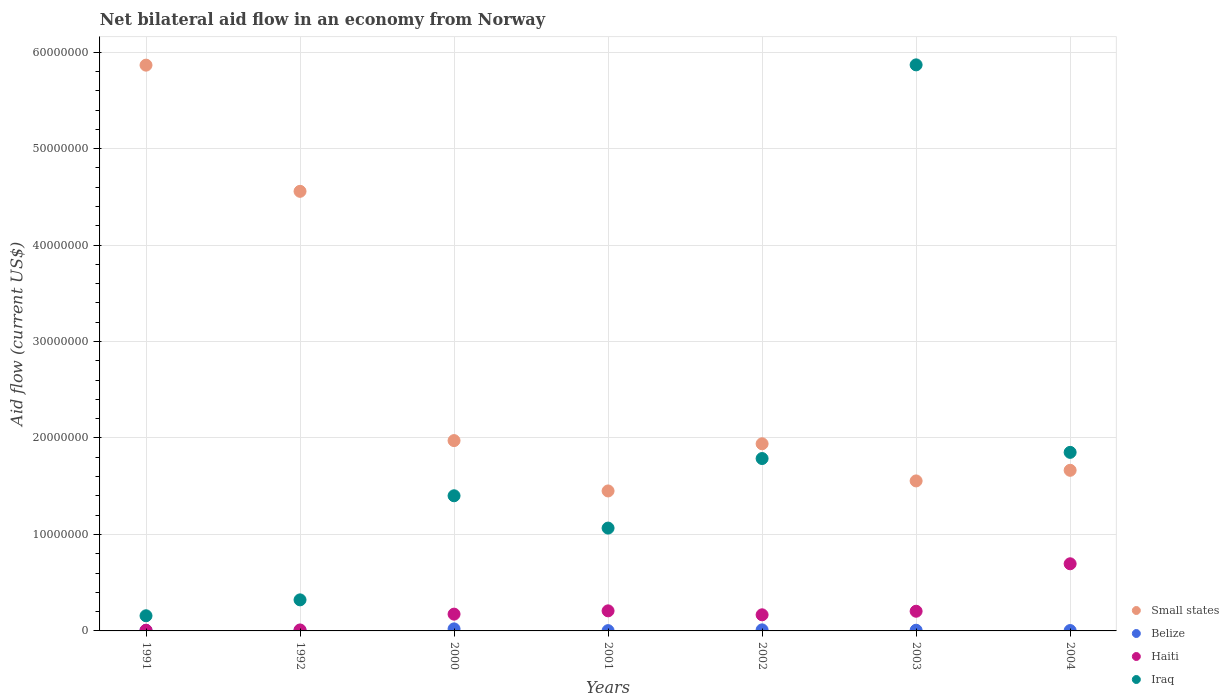Is the number of dotlines equal to the number of legend labels?
Provide a succinct answer. Yes. What is the net bilateral aid flow in Small states in 2000?
Give a very brief answer. 1.97e+07. Across all years, what is the maximum net bilateral aid flow in Iraq?
Make the answer very short. 5.87e+07. In which year was the net bilateral aid flow in Small states maximum?
Offer a terse response. 1991. What is the total net bilateral aid flow in Iraq in the graph?
Your answer should be compact. 1.25e+08. What is the difference between the net bilateral aid flow in Iraq in 1992 and that in 2003?
Keep it short and to the point. -5.55e+07. What is the difference between the net bilateral aid flow in Small states in 1991 and the net bilateral aid flow in Belize in 2002?
Provide a succinct answer. 5.85e+07. What is the average net bilateral aid flow in Small states per year?
Your answer should be compact. 2.72e+07. In the year 1992, what is the difference between the net bilateral aid flow in Iraq and net bilateral aid flow in Small states?
Ensure brevity in your answer.  -4.24e+07. In how many years, is the net bilateral aid flow in Haiti greater than 50000000 US$?
Give a very brief answer. 0. What is the ratio of the net bilateral aid flow in Iraq in 1991 to that in 2003?
Give a very brief answer. 0.03. Is the difference between the net bilateral aid flow in Iraq in 2000 and 2003 greater than the difference between the net bilateral aid flow in Small states in 2000 and 2003?
Offer a very short reply. No. What is the difference between the highest and the second highest net bilateral aid flow in Haiti?
Give a very brief answer. 4.88e+06. In how many years, is the net bilateral aid flow in Small states greater than the average net bilateral aid flow in Small states taken over all years?
Offer a very short reply. 2. Is it the case that in every year, the sum of the net bilateral aid flow in Iraq and net bilateral aid flow in Small states  is greater than the net bilateral aid flow in Belize?
Provide a short and direct response. Yes. Is the net bilateral aid flow in Haiti strictly less than the net bilateral aid flow in Small states over the years?
Provide a succinct answer. Yes. How many years are there in the graph?
Provide a short and direct response. 7. Does the graph contain any zero values?
Give a very brief answer. No. Does the graph contain grids?
Offer a very short reply. Yes. Where does the legend appear in the graph?
Give a very brief answer. Bottom right. How are the legend labels stacked?
Provide a succinct answer. Vertical. What is the title of the graph?
Provide a succinct answer. Net bilateral aid flow in an economy from Norway. What is the label or title of the X-axis?
Offer a very short reply. Years. What is the label or title of the Y-axis?
Ensure brevity in your answer.  Aid flow (current US$). What is the Aid flow (current US$) of Small states in 1991?
Keep it short and to the point. 5.86e+07. What is the Aid flow (current US$) in Belize in 1991?
Keep it short and to the point. 6.00e+04. What is the Aid flow (current US$) in Haiti in 1991?
Keep it short and to the point. 7.00e+04. What is the Aid flow (current US$) in Iraq in 1991?
Give a very brief answer. 1.57e+06. What is the Aid flow (current US$) of Small states in 1992?
Make the answer very short. 4.56e+07. What is the Aid flow (current US$) in Belize in 1992?
Your answer should be very brief. 6.00e+04. What is the Aid flow (current US$) of Haiti in 1992?
Offer a terse response. 1.00e+05. What is the Aid flow (current US$) of Iraq in 1992?
Offer a terse response. 3.22e+06. What is the Aid flow (current US$) in Small states in 2000?
Your answer should be very brief. 1.97e+07. What is the Aid flow (current US$) of Belize in 2000?
Ensure brevity in your answer.  2.10e+05. What is the Aid flow (current US$) in Haiti in 2000?
Your answer should be very brief. 1.74e+06. What is the Aid flow (current US$) in Iraq in 2000?
Your answer should be very brief. 1.40e+07. What is the Aid flow (current US$) in Small states in 2001?
Your answer should be compact. 1.45e+07. What is the Aid flow (current US$) of Haiti in 2001?
Your response must be concise. 2.08e+06. What is the Aid flow (current US$) of Iraq in 2001?
Ensure brevity in your answer.  1.07e+07. What is the Aid flow (current US$) of Small states in 2002?
Provide a succinct answer. 1.94e+07. What is the Aid flow (current US$) of Haiti in 2002?
Your answer should be very brief. 1.67e+06. What is the Aid flow (current US$) in Iraq in 2002?
Your response must be concise. 1.79e+07. What is the Aid flow (current US$) in Small states in 2003?
Your response must be concise. 1.56e+07. What is the Aid flow (current US$) of Belize in 2003?
Offer a terse response. 7.00e+04. What is the Aid flow (current US$) in Haiti in 2003?
Your response must be concise. 2.04e+06. What is the Aid flow (current US$) of Iraq in 2003?
Make the answer very short. 5.87e+07. What is the Aid flow (current US$) of Small states in 2004?
Provide a short and direct response. 1.66e+07. What is the Aid flow (current US$) in Belize in 2004?
Keep it short and to the point. 4.00e+04. What is the Aid flow (current US$) of Haiti in 2004?
Your answer should be very brief. 6.96e+06. What is the Aid flow (current US$) in Iraq in 2004?
Keep it short and to the point. 1.85e+07. Across all years, what is the maximum Aid flow (current US$) of Small states?
Provide a short and direct response. 5.86e+07. Across all years, what is the maximum Aid flow (current US$) in Haiti?
Your response must be concise. 6.96e+06. Across all years, what is the maximum Aid flow (current US$) of Iraq?
Provide a succinct answer. 5.87e+07. Across all years, what is the minimum Aid flow (current US$) of Small states?
Make the answer very short. 1.45e+07. Across all years, what is the minimum Aid flow (current US$) in Haiti?
Your response must be concise. 7.00e+04. Across all years, what is the minimum Aid flow (current US$) in Iraq?
Give a very brief answer. 1.57e+06. What is the total Aid flow (current US$) of Small states in the graph?
Ensure brevity in your answer.  1.90e+08. What is the total Aid flow (current US$) in Belize in the graph?
Make the answer very short. 5.80e+05. What is the total Aid flow (current US$) in Haiti in the graph?
Make the answer very short. 1.47e+07. What is the total Aid flow (current US$) of Iraq in the graph?
Your answer should be compact. 1.25e+08. What is the difference between the Aid flow (current US$) of Small states in 1991 and that in 1992?
Provide a short and direct response. 1.31e+07. What is the difference between the Aid flow (current US$) of Haiti in 1991 and that in 1992?
Your response must be concise. -3.00e+04. What is the difference between the Aid flow (current US$) of Iraq in 1991 and that in 1992?
Your response must be concise. -1.65e+06. What is the difference between the Aid flow (current US$) in Small states in 1991 and that in 2000?
Provide a short and direct response. 3.89e+07. What is the difference between the Aid flow (current US$) in Haiti in 1991 and that in 2000?
Your response must be concise. -1.67e+06. What is the difference between the Aid flow (current US$) of Iraq in 1991 and that in 2000?
Your response must be concise. -1.24e+07. What is the difference between the Aid flow (current US$) of Small states in 1991 and that in 2001?
Your response must be concise. 4.41e+07. What is the difference between the Aid flow (current US$) of Belize in 1991 and that in 2001?
Offer a terse response. 3.00e+04. What is the difference between the Aid flow (current US$) in Haiti in 1991 and that in 2001?
Make the answer very short. -2.01e+06. What is the difference between the Aid flow (current US$) of Iraq in 1991 and that in 2001?
Keep it short and to the point. -9.09e+06. What is the difference between the Aid flow (current US$) of Small states in 1991 and that in 2002?
Your answer should be very brief. 3.92e+07. What is the difference between the Aid flow (current US$) in Belize in 1991 and that in 2002?
Offer a terse response. -5.00e+04. What is the difference between the Aid flow (current US$) in Haiti in 1991 and that in 2002?
Your answer should be compact. -1.60e+06. What is the difference between the Aid flow (current US$) of Iraq in 1991 and that in 2002?
Keep it short and to the point. -1.63e+07. What is the difference between the Aid flow (current US$) in Small states in 1991 and that in 2003?
Offer a very short reply. 4.31e+07. What is the difference between the Aid flow (current US$) in Belize in 1991 and that in 2003?
Offer a terse response. -10000. What is the difference between the Aid flow (current US$) in Haiti in 1991 and that in 2003?
Offer a terse response. -1.97e+06. What is the difference between the Aid flow (current US$) of Iraq in 1991 and that in 2003?
Offer a very short reply. -5.71e+07. What is the difference between the Aid flow (current US$) of Small states in 1991 and that in 2004?
Offer a very short reply. 4.20e+07. What is the difference between the Aid flow (current US$) in Haiti in 1991 and that in 2004?
Provide a succinct answer. -6.89e+06. What is the difference between the Aid flow (current US$) in Iraq in 1991 and that in 2004?
Give a very brief answer. -1.69e+07. What is the difference between the Aid flow (current US$) of Small states in 1992 and that in 2000?
Provide a succinct answer. 2.58e+07. What is the difference between the Aid flow (current US$) of Belize in 1992 and that in 2000?
Provide a short and direct response. -1.50e+05. What is the difference between the Aid flow (current US$) of Haiti in 1992 and that in 2000?
Make the answer very short. -1.64e+06. What is the difference between the Aid flow (current US$) in Iraq in 1992 and that in 2000?
Keep it short and to the point. -1.08e+07. What is the difference between the Aid flow (current US$) of Small states in 1992 and that in 2001?
Make the answer very short. 3.11e+07. What is the difference between the Aid flow (current US$) in Belize in 1992 and that in 2001?
Provide a short and direct response. 3.00e+04. What is the difference between the Aid flow (current US$) of Haiti in 1992 and that in 2001?
Keep it short and to the point. -1.98e+06. What is the difference between the Aid flow (current US$) of Iraq in 1992 and that in 2001?
Your response must be concise. -7.44e+06. What is the difference between the Aid flow (current US$) of Small states in 1992 and that in 2002?
Offer a very short reply. 2.62e+07. What is the difference between the Aid flow (current US$) of Belize in 1992 and that in 2002?
Your answer should be compact. -5.00e+04. What is the difference between the Aid flow (current US$) in Haiti in 1992 and that in 2002?
Keep it short and to the point. -1.57e+06. What is the difference between the Aid flow (current US$) in Iraq in 1992 and that in 2002?
Your response must be concise. -1.46e+07. What is the difference between the Aid flow (current US$) of Small states in 1992 and that in 2003?
Provide a succinct answer. 3.00e+07. What is the difference between the Aid flow (current US$) in Haiti in 1992 and that in 2003?
Your answer should be very brief. -1.94e+06. What is the difference between the Aid flow (current US$) in Iraq in 1992 and that in 2003?
Provide a short and direct response. -5.55e+07. What is the difference between the Aid flow (current US$) in Small states in 1992 and that in 2004?
Provide a short and direct response. 2.89e+07. What is the difference between the Aid flow (current US$) of Haiti in 1992 and that in 2004?
Provide a succinct answer. -6.86e+06. What is the difference between the Aid flow (current US$) of Iraq in 1992 and that in 2004?
Keep it short and to the point. -1.53e+07. What is the difference between the Aid flow (current US$) of Small states in 2000 and that in 2001?
Provide a short and direct response. 5.22e+06. What is the difference between the Aid flow (current US$) of Haiti in 2000 and that in 2001?
Provide a short and direct response. -3.40e+05. What is the difference between the Aid flow (current US$) in Iraq in 2000 and that in 2001?
Ensure brevity in your answer.  3.35e+06. What is the difference between the Aid flow (current US$) of Iraq in 2000 and that in 2002?
Your response must be concise. -3.86e+06. What is the difference between the Aid flow (current US$) in Small states in 2000 and that in 2003?
Offer a very short reply. 4.18e+06. What is the difference between the Aid flow (current US$) in Haiti in 2000 and that in 2003?
Your response must be concise. -3.00e+05. What is the difference between the Aid flow (current US$) of Iraq in 2000 and that in 2003?
Provide a succinct answer. -4.47e+07. What is the difference between the Aid flow (current US$) of Small states in 2000 and that in 2004?
Your response must be concise. 3.08e+06. What is the difference between the Aid flow (current US$) in Belize in 2000 and that in 2004?
Ensure brevity in your answer.  1.70e+05. What is the difference between the Aid flow (current US$) in Haiti in 2000 and that in 2004?
Your response must be concise. -5.22e+06. What is the difference between the Aid flow (current US$) of Iraq in 2000 and that in 2004?
Your response must be concise. -4.50e+06. What is the difference between the Aid flow (current US$) in Small states in 2001 and that in 2002?
Offer a terse response. -4.89e+06. What is the difference between the Aid flow (current US$) in Belize in 2001 and that in 2002?
Provide a succinct answer. -8.00e+04. What is the difference between the Aid flow (current US$) in Iraq in 2001 and that in 2002?
Make the answer very short. -7.21e+06. What is the difference between the Aid flow (current US$) of Small states in 2001 and that in 2003?
Your answer should be compact. -1.04e+06. What is the difference between the Aid flow (current US$) of Belize in 2001 and that in 2003?
Give a very brief answer. -4.00e+04. What is the difference between the Aid flow (current US$) in Iraq in 2001 and that in 2003?
Provide a short and direct response. -4.80e+07. What is the difference between the Aid flow (current US$) in Small states in 2001 and that in 2004?
Provide a short and direct response. -2.14e+06. What is the difference between the Aid flow (current US$) in Haiti in 2001 and that in 2004?
Your response must be concise. -4.88e+06. What is the difference between the Aid flow (current US$) of Iraq in 2001 and that in 2004?
Ensure brevity in your answer.  -7.85e+06. What is the difference between the Aid flow (current US$) in Small states in 2002 and that in 2003?
Your answer should be compact. 3.85e+06. What is the difference between the Aid flow (current US$) in Haiti in 2002 and that in 2003?
Make the answer very short. -3.70e+05. What is the difference between the Aid flow (current US$) of Iraq in 2002 and that in 2003?
Ensure brevity in your answer.  -4.08e+07. What is the difference between the Aid flow (current US$) in Small states in 2002 and that in 2004?
Your response must be concise. 2.75e+06. What is the difference between the Aid flow (current US$) of Belize in 2002 and that in 2004?
Your answer should be very brief. 7.00e+04. What is the difference between the Aid flow (current US$) in Haiti in 2002 and that in 2004?
Your answer should be compact. -5.29e+06. What is the difference between the Aid flow (current US$) in Iraq in 2002 and that in 2004?
Make the answer very short. -6.40e+05. What is the difference between the Aid flow (current US$) of Small states in 2003 and that in 2004?
Make the answer very short. -1.10e+06. What is the difference between the Aid flow (current US$) in Belize in 2003 and that in 2004?
Make the answer very short. 3.00e+04. What is the difference between the Aid flow (current US$) of Haiti in 2003 and that in 2004?
Ensure brevity in your answer.  -4.92e+06. What is the difference between the Aid flow (current US$) of Iraq in 2003 and that in 2004?
Ensure brevity in your answer.  4.02e+07. What is the difference between the Aid flow (current US$) of Small states in 1991 and the Aid flow (current US$) of Belize in 1992?
Offer a terse response. 5.86e+07. What is the difference between the Aid flow (current US$) of Small states in 1991 and the Aid flow (current US$) of Haiti in 1992?
Ensure brevity in your answer.  5.86e+07. What is the difference between the Aid flow (current US$) of Small states in 1991 and the Aid flow (current US$) of Iraq in 1992?
Provide a short and direct response. 5.54e+07. What is the difference between the Aid flow (current US$) of Belize in 1991 and the Aid flow (current US$) of Haiti in 1992?
Make the answer very short. -4.00e+04. What is the difference between the Aid flow (current US$) in Belize in 1991 and the Aid flow (current US$) in Iraq in 1992?
Make the answer very short. -3.16e+06. What is the difference between the Aid flow (current US$) in Haiti in 1991 and the Aid flow (current US$) in Iraq in 1992?
Provide a succinct answer. -3.15e+06. What is the difference between the Aid flow (current US$) in Small states in 1991 and the Aid flow (current US$) in Belize in 2000?
Your answer should be compact. 5.84e+07. What is the difference between the Aid flow (current US$) in Small states in 1991 and the Aid flow (current US$) in Haiti in 2000?
Keep it short and to the point. 5.69e+07. What is the difference between the Aid flow (current US$) of Small states in 1991 and the Aid flow (current US$) of Iraq in 2000?
Provide a short and direct response. 4.46e+07. What is the difference between the Aid flow (current US$) in Belize in 1991 and the Aid flow (current US$) in Haiti in 2000?
Your answer should be compact. -1.68e+06. What is the difference between the Aid flow (current US$) of Belize in 1991 and the Aid flow (current US$) of Iraq in 2000?
Your answer should be very brief. -1.40e+07. What is the difference between the Aid flow (current US$) in Haiti in 1991 and the Aid flow (current US$) in Iraq in 2000?
Give a very brief answer. -1.39e+07. What is the difference between the Aid flow (current US$) in Small states in 1991 and the Aid flow (current US$) in Belize in 2001?
Give a very brief answer. 5.86e+07. What is the difference between the Aid flow (current US$) in Small states in 1991 and the Aid flow (current US$) in Haiti in 2001?
Ensure brevity in your answer.  5.66e+07. What is the difference between the Aid flow (current US$) of Small states in 1991 and the Aid flow (current US$) of Iraq in 2001?
Your answer should be compact. 4.80e+07. What is the difference between the Aid flow (current US$) in Belize in 1991 and the Aid flow (current US$) in Haiti in 2001?
Ensure brevity in your answer.  -2.02e+06. What is the difference between the Aid flow (current US$) of Belize in 1991 and the Aid flow (current US$) of Iraq in 2001?
Provide a succinct answer. -1.06e+07. What is the difference between the Aid flow (current US$) of Haiti in 1991 and the Aid flow (current US$) of Iraq in 2001?
Offer a very short reply. -1.06e+07. What is the difference between the Aid flow (current US$) in Small states in 1991 and the Aid flow (current US$) in Belize in 2002?
Offer a very short reply. 5.85e+07. What is the difference between the Aid flow (current US$) in Small states in 1991 and the Aid flow (current US$) in Haiti in 2002?
Offer a terse response. 5.70e+07. What is the difference between the Aid flow (current US$) in Small states in 1991 and the Aid flow (current US$) in Iraq in 2002?
Provide a short and direct response. 4.08e+07. What is the difference between the Aid flow (current US$) in Belize in 1991 and the Aid flow (current US$) in Haiti in 2002?
Your answer should be compact. -1.61e+06. What is the difference between the Aid flow (current US$) of Belize in 1991 and the Aid flow (current US$) of Iraq in 2002?
Offer a terse response. -1.78e+07. What is the difference between the Aid flow (current US$) of Haiti in 1991 and the Aid flow (current US$) of Iraq in 2002?
Provide a succinct answer. -1.78e+07. What is the difference between the Aid flow (current US$) of Small states in 1991 and the Aid flow (current US$) of Belize in 2003?
Ensure brevity in your answer.  5.86e+07. What is the difference between the Aid flow (current US$) in Small states in 1991 and the Aid flow (current US$) in Haiti in 2003?
Offer a very short reply. 5.66e+07. What is the difference between the Aid flow (current US$) in Belize in 1991 and the Aid flow (current US$) in Haiti in 2003?
Give a very brief answer. -1.98e+06. What is the difference between the Aid flow (current US$) of Belize in 1991 and the Aid flow (current US$) of Iraq in 2003?
Your answer should be very brief. -5.86e+07. What is the difference between the Aid flow (current US$) in Haiti in 1991 and the Aid flow (current US$) in Iraq in 2003?
Provide a short and direct response. -5.86e+07. What is the difference between the Aid flow (current US$) in Small states in 1991 and the Aid flow (current US$) in Belize in 2004?
Keep it short and to the point. 5.86e+07. What is the difference between the Aid flow (current US$) in Small states in 1991 and the Aid flow (current US$) in Haiti in 2004?
Your answer should be compact. 5.17e+07. What is the difference between the Aid flow (current US$) of Small states in 1991 and the Aid flow (current US$) of Iraq in 2004?
Keep it short and to the point. 4.01e+07. What is the difference between the Aid flow (current US$) of Belize in 1991 and the Aid flow (current US$) of Haiti in 2004?
Offer a very short reply. -6.90e+06. What is the difference between the Aid flow (current US$) in Belize in 1991 and the Aid flow (current US$) in Iraq in 2004?
Give a very brief answer. -1.84e+07. What is the difference between the Aid flow (current US$) of Haiti in 1991 and the Aid flow (current US$) of Iraq in 2004?
Give a very brief answer. -1.84e+07. What is the difference between the Aid flow (current US$) in Small states in 1992 and the Aid flow (current US$) in Belize in 2000?
Your answer should be compact. 4.54e+07. What is the difference between the Aid flow (current US$) of Small states in 1992 and the Aid flow (current US$) of Haiti in 2000?
Offer a very short reply. 4.38e+07. What is the difference between the Aid flow (current US$) in Small states in 1992 and the Aid flow (current US$) in Iraq in 2000?
Your response must be concise. 3.16e+07. What is the difference between the Aid flow (current US$) in Belize in 1992 and the Aid flow (current US$) in Haiti in 2000?
Make the answer very short. -1.68e+06. What is the difference between the Aid flow (current US$) of Belize in 1992 and the Aid flow (current US$) of Iraq in 2000?
Your response must be concise. -1.40e+07. What is the difference between the Aid flow (current US$) in Haiti in 1992 and the Aid flow (current US$) in Iraq in 2000?
Your answer should be very brief. -1.39e+07. What is the difference between the Aid flow (current US$) of Small states in 1992 and the Aid flow (current US$) of Belize in 2001?
Your response must be concise. 4.55e+07. What is the difference between the Aid flow (current US$) in Small states in 1992 and the Aid flow (current US$) in Haiti in 2001?
Give a very brief answer. 4.35e+07. What is the difference between the Aid flow (current US$) in Small states in 1992 and the Aid flow (current US$) in Iraq in 2001?
Give a very brief answer. 3.49e+07. What is the difference between the Aid flow (current US$) of Belize in 1992 and the Aid flow (current US$) of Haiti in 2001?
Give a very brief answer. -2.02e+06. What is the difference between the Aid flow (current US$) in Belize in 1992 and the Aid flow (current US$) in Iraq in 2001?
Give a very brief answer. -1.06e+07. What is the difference between the Aid flow (current US$) of Haiti in 1992 and the Aid flow (current US$) of Iraq in 2001?
Your answer should be compact. -1.06e+07. What is the difference between the Aid flow (current US$) of Small states in 1992 and the Aid flow (current US$) of Belize in 2002?
Your answer should be very brief. 4.55e+07. What is the difference between the Aid flow (current US$) of Small states in 1992 and the Aid flow (current US$) of Haiti in 2002?
Offer a very short reply. 4.39e+07. What is the difference between the Aid flow (current US$) of Small states in 1992 and the Aid flow (current US$) of Iraq in 2002?
Your answer should be very brief. 2.77e+07. What is the difference between the Aid flow (current US$) in Belize in 1992 and the Aid flow (current US$) in Haiti in 2002?
Ensure brevity in your answer.  -1.61e+06. What is the difference between the Aid flow (current US$) of Belize in 1992 and the Aid flow (current US$) of Iraq in 2002?
Your answer should be compact. -1.78e+07. What is the difference between the Aid flow (current US$) of Haiti in 1992 and the Aid flow (current US$) of Iraq in 2002?
Keep it short and to the point. -1.78e+07. What is the difference between the Aid flow (current US$) in Small states in 1992 and the Aid flow (current US$) in Belize in 2003?
Your response must be concise. 4.55e+07. What is the difference between the Aid flow (current US$) in Small states in 1992 and the Aid flow (current US$) in Haiti in 2003?
Your answer should be compact. 4.35e+07. What is the difference between the Aid flow (current US$) in Small states in 1992 and the Aid flow (current US$) in Iraq in 2003?
Your response must be concise. -1.31e+07. What is the difference between the Aid flow (current US$) of Belize in 1992 and the Aid flow (current US$) of Haiti in 2003?
Give a very brief answer. -1.98e+06. What is the difference between the Aid flow (current US$) of Belize in 1992 and the Aid flow (current US$) of Iraq in 2003?
Your response must be concise. -5.86e+07. What is the difference between the Aid flow (current US$) in Haiti in 1992 and the Aid flow (current US$) in Iraq in 2003?
Provide a short and direct response. -5.86e+07. What is the difference between the Aid flow (current US$) in Small states in 1992 and the Aid flow (current US$) in Belize in 2004?
Your answer should be compact. 4.55e+07. What is the difference between the Aid flow (current US$) in Small states in 1992 and the Aid flow (current US$) in Haiti in 2004?
Your answer should be very brief. 3.86e+07. What is the difference between the Aid flow (current US$) in Small states in 1992 and the Aid flow (current US$) in Iraq in 2004?
Your response must be concise. 2.71e+07. What is the difference between the Aid flow (current US$) in Belize in 1992 and the Aid flow (current US$) in Haiti in 2004?
Ensure brevity in your answer.  -6.90e+06. What is the difference between the Aid flow (current US$) of Belize in 1992 and the Aid flow (current US$) of Iraq in 2004?
Provide a short and direct response. -1.84e+07. What is the difference between the Aid flow (current US$) of Haiti in 1992 and the Aid flow (current US$) of Iraq in 2004?
Provide a succinct answer. -1.84e+07. What is the difference between the Aid flow (current US$) in Small states in 2000 and the Aid flow (current US$) in Belize in 2001?
Make the answer very short. 1.97e+07. What is the difference between the Aid flow (current US$) of Small states in 2000 and the Aid flow (current US$) of Haiti in 2001?
Your answer should be compact. 1.76e+07. What is the difference between the Aid flow (current US$) of Small states in 2000 and the Aid flow (current US$) of Iraq in 2001?
Offer a very short reply. 9.07e+06. What is the difference between the Aid flow (current US$) in Belize in 2000 and the Aid flow (current US$) in Haiti in 2001?
Ensure brevity in your answer.  -1.87e+06. What is the difference between the Aid flow (current US$) in Belize in 2000 and the Aid flow (current US$) in Iraq in 2001?
Give a very brief answer. -1.04e+07. What is the difference between the Aid flow (current US$) in Haiti in 2000 and the Aid flow (current US$) in Iraq in 2001?
Make the answer very short. -8.92e+06. What is the difference between the Aid flow (current US$) in Small states in 2000 and the Aid flow (current US$) in Belize in 2002?
Provide a succinct answer. 1.96e+07. What is the difference between the Aid flow (current US$) in Small states in 2000 and the Aid flow (current US$) in Haiti in 2002?
Offer a very short reply. 1.81e+07. What is the difference between the Aid flow (current US$) in Small states in 2000 and the Aid flow (current US$) in Iraq in 2002?
Offer a terse response. 1.86e+06. What is the difference between the Aid flow (current US$) in Belize in 2000 and the Aid flow (current US$) in Haiti in 2002?
Provide a succinct answer. -1.46e+06. What is the difference between the Aid flow (current US$) of Belize in 2000 and the Aid flow (current US$) of Iraq in 2002?
Offer a very short reply. -1.77e+07. What is the difference between the Aid flow (current US$) in Haiti in 2000 and the Aid flow (current US$) in Iraq in 2002?
Offer a very short reply. -1.61e+07. What is the difference between the Aid flow (current US$) of Small states in 2000 and the Aid flow (current US$) of Belize in 2003?
Make the answer very short. 1.97e+07. What is the difference between the Aid flow (current US$) in Small states in 2000 and the Aid flow (current US$) in Haiti in 2003?
Your answer should be compact. 1.77e+07. What is the difference between the Aid flow (current US$) in Small states in 2000 and the Aid flow (current US$) in Iraq in 2003?
Offer a very short reply. -3.90e+07. What is the difference between the Aid flow (current US$) in Belize in 2000 and the Aid flow (current US$) in Haiti in 2003?
Your response must be concise. -1.83e+06. What is the difference between the Aid flow (current US$) in Belize in 2000 and the Aid flow (current US$) in Iraq in 2003?
Provide a short and direct response. -5.85e+07. What is the difference between the Aid flow (current US$) of Haiti in 2000 and the Aid flow (current US$) of Iraq in 2003?
Offer a terse response. -5.69e+07. What is the difference between the Aid flow (current US$) in Small states in 2000 and the Aid flow (current US$) in Belize in 2004?
Provide a succinct answer. 1.97e+07. What is the difference between the Aid flow (current US$) of Small states in 2000 and the Aid flow (current US$) of Haiti in 2004?
Make the answer very short. 1.28e+07. What is the difference between the Aid flow (current US$) of Small states in 2000 and the Aid flow (current US$) of Iraq in 2004?
Your response must be concise. 1.22e+06. What is the difference between the Aid flow (current US$) of Belize in 2000 and the Aid flow (current US$) of Haiti in 2004?
Offer a terse response. -6.75e+06. What is the difference between the Aid flow (current US$) in Belize in 2000 and the Aid flow (current US$) in Iraq in 2004?
Your response must be concise. -1.83e+07. What is the difference between the Aid flow (current US$) of Haiti in 2000 and the Aid flow (current US$) of Iraq in 2004?
Make the answer very short. -1.68e+07. What is the difference between the Aid flow (current US$) in Small states in 2001 and the Aid flow (current US$) in Belize in 2002?
Provide a succinct answer. 1.44e+07. What is the difference between the Aid flow (current US$) of Small states in 2001 and the Aid flow (current US$) of Haiti in 2002?
Your response must be concise. 1.28e+07. What is the difference between the Aid flow (current US$) of Small states in 2001 and the Aid flow (current US$) of Iraq in 2002?
Your answer should be compact. -3.36e+06. What is the difference between the Aid flow (current US$) of Belize in 2001 and the Aid flow (current US$) of Haiti in 2002?
Give a very brief answer. -1.64e+06. What is the difference between the Aid flow (current US$) in Belize in 2001 and the Aid flow (current US$) in Iraq in 2002?
Your response must be concise. -1.78e+07. What is the difference between the Aid flow (current US$) in Haiti in 2001 and the Aid flow (current US$) in Iraq in 2002?
Give a very brief answer. -1.58e+07. What is the difference between the Aid flow (current US$) of Small states in 2001 and the Aid flow (current US$) of Belize in 2003?
Give a very brief answer. 1.44e+07. What is the difference between the Aid flow (current US$) in Small states in 2001 and the Aid flow (current US$) in Haiti in 2003?
Keep it short and to the point. 1.25e+07. What is the difference between the Aid flow (current US$) of Small states in 2001 and the Aid flow (current US$) of Iraq in 2003?
Provide a short and direct response. -4.42e+07. What is the difference between the Aid flow (current US$) in Belize in 2001 and the Aid flow (current US$) in Haiti in 2003?
Ensure brevity in your answer.  -2.01e+06. What is the difference between the Aid flow (current US$) in Belize in 2001 and the Aid flow (current US$) in Iraq in 2003?
Ensure brevity in your answer.  -5.86e+07. What is the difference between the Aid flow (current US$) in Haiti in 2001 and the Aid flow (current US$) in Iraq in 2003?
Your answer should be very brief. -5.66e+07. What is the difference between the Aid flow (current US$) of Small states in 2001 and the Aid flow (current US$) of Belize in 2004?
Offer a terse response. 1.45e+07. What is the difference between the Aid flow (current US$) of Small states in 2001 and the Aid flow (current US$) of Haiti in 2004?
Ensure brevity in your answer.  7.55e+06. What is the difference between the Aid flow (current US$) in Belize in 2001 and the Aid flow (current US$) in Haiti in 2004?
Provide a short and direct response. -6.93e+06. What is the difference between the Aid flow (current US$) of Belize in 2001 and the Aid flow (current US$) of Iraq in 2004?
Make the answer very short. -1.85e+07. What is the difference between the Aid flow (current US$) of Haiti in 2001 and the Aid flow (current US$) of Iraq in 2004?
Offer a terse response. -1.64e+07. What is the difference between the Aid flow (current US$) of Small states in 2002 and the Aid flow (current US$) of Belize in 2003?
Your answer should be very brief. 1.93e+07. What is the difference between the Aid flow (current US$) of Small states in 2002 and the Aid flow (current US$) of Haiti in 2003?
Keep it short and to the point. 1.74e+07. What is the difference between the Aid flow (current US$) in Small states in 2002 and the Aid flow (current US$) in Iraq in 2003?
Provide a short and direct response. -3.93e+07. What is the difference between the Aid flow (current US$) of Belize in 2002 and the Aid flow (current US$) of Haiti in 2003?
Keep it short and to the point. -1.93e+06. What is the difference between the Aid flow (current US$) of Belize in 2002 and the Aid flow (current US$) of Iraq in 2003?
Your response must be concise. -5.86e+07. What is the difference between the Aid flow (current US$) in Haiti in 2002 and the Aid flow (current US$) in Iraq in 2003?
Provide a succinct answer. -5.70e+07. What is the difference between the Aid flow (current US$) of Small states in 2002 and the Aid flow (current US$) of Belize in 2004?
Keep it short and to the point. 1.94e+07. What is the difference between the Aid flow (current US$) in Small states in 2002 and the Aid flow (current US$) in Haiti in 2004?
Offer a very short reply. 1.24e+07. What is the difference between the Aid flow (current US$) of Small states in 2002 and the Aid flow (current US$) of Iraq in 2004?
Give a very brief answer. 8.90e+05. What is the difference between the Aid flow (current US$) of Belize in 2002 and the Aid flow (current US$) of Haiti in 2004?
Your answer should be compact. -6.85e+06. What is the difference between the Aid flow (current US$) of Belize in 2002 and the Aid flow (current US$) of Iraq in 2004?
Ensure brevity in your answer.  -1.84e+07. What is the difference between the Aid flow (current US$) of Haiti in 2002 and the Aid flow (current US$) of Iraq in 2004?
Ensure brevity in your answer.  -1.68e+07. What is the difference between the Aid flow (current US$) in Small states in 2003 and the Aid flow (current US$) in Belize in 2004?
Give a very brief answer. 1.55e+07. What is the difference between the Aid flow (current US$) in Small states in 2003 and the Aid flow (current US$) in Haiti in 2004?
Offer a terse response. 8.59e+06. What is the difference between the Aid flow (current US$) in Small states in 2003 and the Aid flow (current US$) in Iraq in 2004?
Provide a succinct answer. -2.96e+06. What is the difference between the Aid flow (current US$) in Belize in 2003 and the Aid flow (current US$) in Haiti in 2004?
Offer a terse response. -6.89e+06. What is the difference between the Aid flow (current US$) of Belize in 2003 and the Aid flow (current US$) of Iraq in 2004?
Make the answer very short. -1.84e+07. What is the difference between the Aid flow (current US$) of Haiti in 2003 and the Aid flow (current US$) of Iraq in 2004?
Offer a terse response. -1.65e+07. What is the average Aid flow (current US$) of Small states per year?
Give a very brief answer. 2.72e+07. What is the average Aid flow (current US$) in Belize per year?
Your answer should be very brief. 8.29e+04. What is the average Aid flow (current US$) in Haiti per year?
Offer a very short reply. 2.09e+06. What is the average Aid flow (current US$) of Iraq per year?
Offer a terse response. 1.78e+07. In the year 1991, what is the difference between the Aid flow (current US$) in Small states and Aid flow (current US$) in Belize?
Ensure brevity in your answer.  5.86e+07. In the year 1991, what is the difference between the Aid flow (current US$) in Small states and Aid flow (current US$) in Haiti?
Your response must be concise. 5.86e+07. In the year 1991, what is the difference between the Aid flow (current US$) of Small states and Aid flow (current US$) of Iraq?
Your answer should be very brief. 5.71e+07. In the year 1991, what is the difference between the Aid flow (current US$) in Belize and Aid flow (current US$) in Haiti?
Offer a very short reply. -10000. In the year 1991, what is the difference between the Aid flow (current US$) in Belize and Aid flow (current US$) in Iraq?
Give a very brief answer. -1.51e+06. In the year 1991, what is the difference between the Aid flow (current US$) in Haiti and Aid flow (current US$) in Iraq?
Provide a short and direct response. -1.50e+06. In the year 1992, what is the difference between the Aid flow (current US$) of Small states and Aid flow (current US$) of Belize?
Provide a short and direct response. 4.55e+07. In the year 1992, what is the difference between the Aid flow (current US$) of Small states and Aid flow (current US$) of Haiti?
Offer a terse response. 4.55e+07. In the year 1992, what is the difference between the Aid flow (current US$) in Small states and Aid flow (current US$) in Iraq?
Provide a short and direct response. 4.24e+07. In the year 1992, what is the difference between the Aid flow (current US$) of Belize and Aid flow (current US$) of Haiti?
Offer a very short reply. -4.00e+04. In the year 1992, what is the difference between the Aid flow (current US$) of Belize and Aid flow (current US$) of Iraq?
Your answer should be compact. -3.16e+06. In the year 1992, what is the difference between the Aid flow (current US$) of Haiti and Aid flow (current US$) of Iraq?
Your response must be concise. -3.12e+06. In the year 2000, what is the difference between the Aid flow (current US$) in Small states and Aid flow (current US$) in Belize?
Your answer should be compact. 1.95e+07. In the year 2000, what is the difference between the Aid flow (current US$) in Small states and Aid flow (current US$) in Haiti?
Provide a succinct answer. 1.80e+07. In the year 2000, what is the difference between the Aid flow (current US$) in Small states and Aid flow (current US$) in Iraq?
Your answer should be compact. 5.72e+06. In the year 2000, what is the difference between the Aid flow (current US$) in Belize and Aid flow (current US$) in Haiti?
Your answer should be compact. -1.53e+06. In the year 2000, what is the difference between the Aid flow (current US$) in Belize and Aid flow (current US$) in Iraq?
Your response must be concise. -1.38e+07. In the year 2000, what is the difference between the Aid flow (current US$) of Haiti and Aid flow (current US$) of Iraq?
Make the answer very short. -1.23e+07. In the year 2001, what is the difference between the Aid flow (current US$) of Small states and Aid flow (current US$) of Belize?
Ensure brevity in your answer.  1.45e+07. In the year 2001, what is the difference between the Aid flow (current US$) of Small states and Aid flow (current US$) of Haiti?
Keep it short and to the point. 1.24e+07. In the year 2001, what is the difference between the Aid flow (current US$) of Small states and Aid flow (current US$) of Iraq?
Keep it short and to the point. 3.85e+06. In the year 2001, what is the difference between the Aid flow (current US$) in Belize and Aid flow (current US$) in Haiti?
Ensure brevity in your answer.  -2.05e+06. In the year 2001, what is the difference between the Aid flow (current US$) of Belize and Aid flow (current US$) of Iraq?
Ensure brevity in your answer.  -1.06e+07. In the year 2001, what is the difference between the Aid flow (current US$) of Haiti and Aid flow (current US$) of Iraq?
Your answer should be compact. -8.58e+06. In the year 2002, what is the difference between the Aid flow (current US$) in Small states and Aid flow (current US$) in Belize?
Provide a succinct answer. 1.93e+07. In the year 2002, what is the difference between the Aid flow (current US$) of Small states and Aid flow (current US$) of Haiti?
Your answer should be compact. 1.77e+07. In the year 2002, what is the difference between the Aid flow (current US$) of Small states and Aid flow (current US$) of Iraq?
Ensure brevity in your answer.  1.53e+06. In the year 2002, what is the difference between the Aid flow (current US$) of Belize and Aid flow (current US$) of Haiti?
Your answer should be very brief. -1.56e+06. In the year 2002, what is the difference between the Aid flow (current US$) of Belize and Aid flow (current US$) of Iraq?
Provide a short and direct response. -1.78e+07. In the year 2002, what is the difference between the Aid flow (current US$) of Haiti and Aid flow (current US$) of Iraq?
Give a very brief answer. -1.62e+07. In the year 2003, what is the difference between the Aid flow (current US$) in Small states and Aid flow (current US$) in Belize?
Ensure brevity in your answer.  1.55e+07. In the year 2003, what is the difference between the Aid flow (current US$) of Small states and Aid flow (current US$) of Haiti?
Keep it short and to the point. 1.35e+07. In the year 2003, what is the difference between the Aid flow (current US$) in Small states and Aid flow (current US$) in Iraq?
Keep it short and to the point. -4.31e+07. In the year 2003, what is the difference between the Aid flow (current US$) of Belize and Aid flow (current US$) of Haiti?
Offer a terse response. -1.97e+06. In the year 2003, what is the difference between the Aid flow (current US$) of Belize and Aid flow (current US$) of Iraq?
Offer a very short reply. -5.86e+07. In the year 2003, what is the difference between the Aid flow (current US$) in Haiti and Aid flow (current US$) in Iraq?
Your response must be concise. -5.66e+07. In the year 2004, what is the difference between the Aid flow (current US$) in Small states and Aid flow (current US$) in Belize?
Offer a terse response. 1.66e+07. In the year 2004, what is the difference between the Aid flow (current US$) in Small states and Aid flow (current US$) in Haiti?
Your response must be concise. 9.69e+06. In the year 2004, what is the difference between the Aid flow (current US$) of Small states and Aid flow (current US$) of Iraq?
Your response must be concise. -1.86e+06. In the year 2004, what is the difference between the Aid flow (current US$) of Belize and Aid flow (current US$) of Haiti?
Provide a short and direct response. -6.92e+06. In the year 2004, what is the difference between the Aid flow (current US$) in Belize and Aid flow (current US$) in Iraq?
Offer a very short reply. -1.85e+07. In the year 2004, what is the difference between the Aid flow (current US$) in Haiti and Aid flow (current US$) in Iraq?
Make the answer very short. -1.16e+07. What is the ratio of the Aid flow (current US$) in Small states in 1991 to that in 1992?
Give a very brief answer. 1.29. What is the ratio of the Aid flow (current US$) of Haiti in 1991 to that in 1992?
Your answer should be very brief. 0.7. What is the ratio of the Aid flow (current US$) of Iraq in 1991 to that in 1992?
Offer a very short reply. 0.49. What is the ratio of the Aid flow (current US$) of Small states in 1991 to that in 2000?
Make the answer very short. 2.97. What is the ratio of the Aid flow (current US$) of Belize in 1991 to that in 2000?
Ensure brevity in your answer.  0.29. What is the ratio of the Aid flow (current US$) of Haiti in 1991 to that in 2000?
Your response must be concise. 0.04. What is the ratio of the Aid flow (current US$) in Iraq in 1991 to that in 2000?
Provide a short and direct response. 0.11. What is the ratio of the Aid flow (current US$) of Small states in 1991 to that in 2001?
Keep it short and to the point. 4.04. What is the ratio of the Aid flow (current US$) in Haiti in 1991 to that in 2001?
Make the answer very short. 0.03. What is the ratio of the Aid flow (current US$) of Iraq in 1991 to that in 2001?
Provide a succinct answer. 0.15. What is the ratio of the Aid flow (current US$) in Small states in 1991 to that in 2002?
Keep it short and to the point. 3.02. What is the ratio of the Aid flow (current US$) of Belize in 1991 to that in 2002?
Offer a very short reply. 0.55. What is the ratio of the Aid flow (current US$) in Haiti in 1991 to that in 2002?
Give a very brief answer. 0.04. What is the ratio of the Aid flow (current US$) of Iraq in 1991 to that in 2002?
Your answer should be very brief. 0.09. What is the ratio of the Aid flow (current US$) of Small states in 1991 to that in 2003?
Make the answer very short. 3.77. What is the ratio of the Aid flow (current US$) of Belize in 1991 to that in 2003?
Your answer should be compact. 0.86. What is the ratio of the Aid flow (current US$) of Haiti in 1991 to that in 2003?
Ensure brevity in your answer.  0.03. What is the ratio of the Aid flow (current US$) in Iraq in 1991 to that in 2003?
Offer a terse response. 0.03. What is the ratio of the Aid flow (current US$) of Small states in 1991 to that in 2004?
Your answer should be compact. 3.52. What is the ratio of the Aid flow (current US$) of Belize in 1991 to that in 2004?
Ensure brevity in your answer.  1.5. What is the ratio of the Aid flow (current US$) in Haiti in 1991 to that in 2004?
Your answer should be compact. 0.01. What is the ratio of the Aid flow (current US$) in Iraq in 1991 to that in 2004?
Give a very brief answer. 0.08. What is the ratio of the Aid flow (current US$) of Small states in 1992 to that in 2000?
Ensure brevity in your answer.  2.31. What is the ratio of the Aid flow (current US$) in Belize in 1992 to that in 2000?
Offer a very short reply. 0.29. What is the ratio of the Aid flow (current US$) in Haiti in 1992 to that in 2000?
Provide a short and direct response. 0.06. What is the ratio of the Aid flow (current US$) of Iraq in 1992 to that in 2000?
Offer a very short reply. 0.23. What is the ratio of the Aid flow (current US$) in Small states in 1992 to that in 2001?
Offer a very short reply. 3.14. What is the ratio of the Aid flow (current US$) of Haiti in 1992 to that in 2001?
Your answer should be very brief. 0.05. What is the ratio of the Aid flow (current US$) of Iraq in 1992 to that in 2001?
Your answer should be compact. 0.3. What is the ratio of the Aid flow (current US$) of Small states in 1992 to that in 2002?
Give a very brief answer. 2.35. What is the ratio of the Aid flow (current US$) in Belize in 1992 to that in 2002?
Make the answer very short. 0.55. What is the ratio of the Aid flow (current US$) of Haiti in 1992 to that in 2002?
Make the answer very short. 0.06. What is the ratio of the Aid flow (current US$) of Iraq in 1992 to that in 2002?
Your answer should be very brief. 0.18. What is the ratio of the Aid flow (current US$) of Small states in 1992 to that in 2003?
Provide a succinct answer. 2.93. What is the ratio of the Aid flow (current US$) of Belize in 1992 to that in 2003?
Offer a very short reply. 0.86. What is the ratio of the Aid flow (current US$) of Haiti in 1992 to that in 2003?
Make the answer very short. 0.05. What is the ratio of the Aid flow (current US$) in Iraq in 1992 to that in 2003?
Your answer should be compact. 0.05. What is the ratio of the Aid flow (current US$) of Small states in 1992 to that in 2004?
Keep it short and to the point. 2.74. What is the ratio of the Aid flow (current US$) of Haiti in 1992 to that in 2004?
Give a very brief answer. 0.01. What is the ratio of the Aid flow (current US$) in Iraq in 1992 to that in 2004?
Your response must be concise. 0.17. What is the ratio of the Aid flow (current US$) in Small states in 2000 to that in 2001?
Provide a short and direct response. 1.36. What is the ratio of the Aid flow (current US$) in Haiti in 2000 to that in 2001?
Keep it short and to the point. 0.84. What is the ratio of the Aid flow (current US$) of Iraq in 2000 to that in 2001?
Offer a very short reply. 1.31. What is the ratio of the Aid flow (current US$) of Belize in 2000 to that in 2002?
Your answer should be compact. 1.91. What is the ratio of the Aid flow (current US$) in Haiti in 2000 to that in 2002?
Your response must be concise. 1.04. What is the ratio of the Aid flow (current US$) in Iraq in 2000 to that in 2002?
Keep it short and to the point. 0.78. What is the ratio of the Aid flow (current US$) in Small states in 2000 to that in 2003?
Your response must be concise. 1.27. What is the ratio of the Aid flow (current US$) in Haiti in 2000 to that in 2003?
Make the answer very short. 0.85. What is the ratio of the Aid flow (current US$) in Iraq in 2000 to that in 2003?
Give a very brief answer. 0.24. What is the ratio of the Aid flow (current US$) of Small states in 2000 to that in 2004?
Provide a short and direct response. 1.19. What is the ratio of the Aid flow (current US$) in Belize in 2000 to that in 2004?
Provide a succinct answer. 5.25. What is the ratio of the Aid flow (current US$) of Iraq in 2000 to that in 2004?
Keep it short and to the point. 0.76. What is the ratio of the Aid flow (current US$) of Small states in 2001 to that in 2002?
Ensure brevity in your answer.  0.75. What is the ratio of the Aid flow (current US$) in Belize in 2001 to that in 2002?
Provide a short and direct response. 0.27. What is the ratio of the Aid flow (current US$) of Haiti in 2001 to that in 2002?
Your answer should be very brief. 1.25. What is the ratio of the Aid flow (current US$) in Iraq in 2001 to that in 2002?
Offer a terse response. 0.6. What is the ratio of the Aid flow (current US$) of Small states in 2001 to that in 2003?
Provide a short and direct response. 0.93. What is the ratio of the Aid flow (current US$) of Belize in 2001 to that in 2003?
Your answer should be compact. 0.43. What is the ratio of the Aid flow (current US$) in Haiti in 2001 to that in 2003?
Make the answer very short. 1.02. What is the ratio of the Aid flow (current US$) of Iraq in 2001 to that in 2003?
Give a very brief answer. 0.18. What is the ratio of the Aid flow (current US$) of Small states in 2001 to that in 2004?
Your answer should be compact. 0.87. What is the ratio of the Aid flow (current US$) of Haiti in 2001 to that in 2004?
Your response must be concise. 0.3. What is the ratio of the Aid flow (current US$) of Iraq in 2001 to that in 2004?
Make the answer very short. 0.58. What is the ratio of the Aid flow (current US$) in Small states in 2002 to that in 2003?
Keep it short and to the point. 1.25. What is the ratio of the Aid flow (current US$) of Belize in 2002 to that in 2003?
Make the answer very short. 1.57. What is the ratio of the Aid flow (current US$) of Haiti in 2002 to that in 2003?
Provide a short and direct response. 0.82. What is the ratio of the Aid flow (current US$) in Iraq in 2002 to that in 2003?
Offer a very short reply. 0.3. What is the ratio of the Aid flow (current US$) of Small states in 2002 to that in 2004?
Make the answer very short. 1.17. What is the ratio of the Aid flow (current US$) in Belize in 2002 to that in 2004?
Your answer should be compact. 2.75. What is the ratio of the Aid flow (current US$) of Haiti in 2002 to that in 2004?
Give a very brief answer. 0.24. What is the ratio of the Aid flow (current US$) in Iraq in 2002 to that in 2004?
Ensure brevity in your answer.  0.97. What is the ratio of the Aid flow (current US$) of Small states in 2003 to that in 2004?
Ensure brevity in your answer.  0.93. What is the ratio of the Aid flow (current US$) of Haiti in 2003 to that in 2004?
Offer a very short reply. 0.29. What is the ratio of the Aid flow (current US$) in Iraq in 2003 to that in 2004?
Offer a very short reply. 3.17. What is the difference between the highest and the second highest Aid flow (current US$) of Small states?
Ensure brevity in your answer.  1.31e+07. What is the difference between the highest and the second highest Aid flow (current US$) in Belize?
Offer a terse response. 1.00e+05. What is the difference between the highest and the second highest Aid flow (current US$) of Haiti?
Your answer should be compact. 4.88e+06. What is the difference between the highest and the second highest Aid flow (current US$) in Iraq?
Your answer should be compact. 4.02e+07. What is the difference between the highest and the lowest Aid flow (current US$) in Small states?
Offer a very short reply. 4.41e+07. What is the difference between the highest and the lowest Aid flow (current US$) of Belize?
Keep it short and to the point. 1.80e+05. What is the difference between the highest and the lowest Aid flow (current US$) in Haiti?
Your answer should be compact. 6.89e+06. What is the difference between the highest and the lowest Aid flow (current US$) in Iraq?
Give a very brief answer. 5.71e+07. 